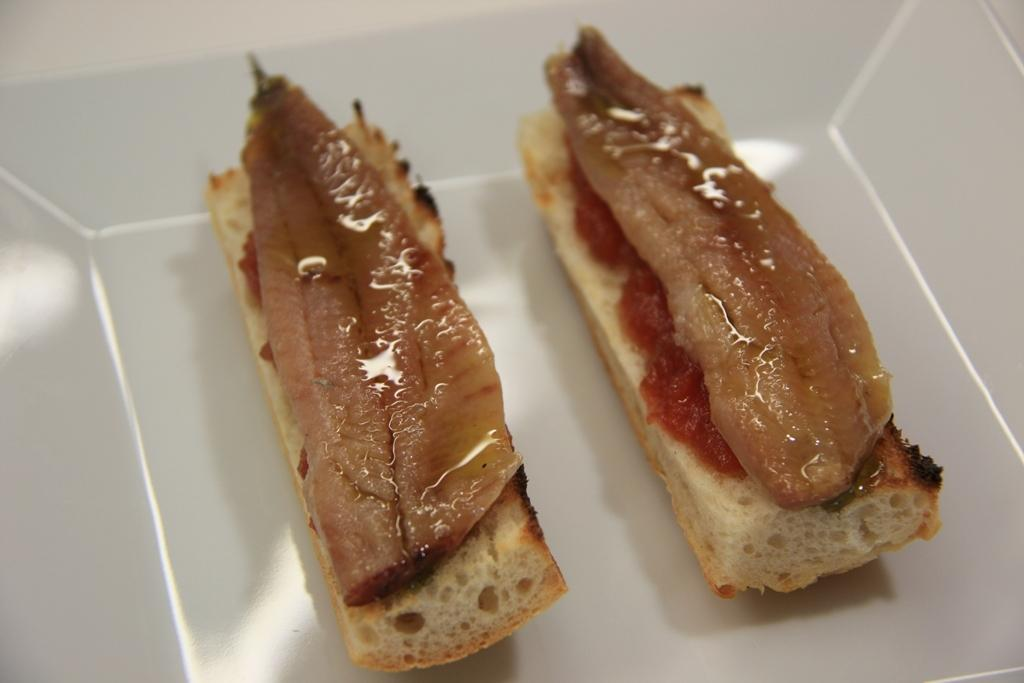What type of items can be seen in the image? There are food items in the image. Where are the food items located? The food items are in a white object. What type of wealth is depicted in the image? There is no depiction of wealth in the image; it features food items in a white object. What type of vessel is used to transport the food items in the image? There is no vessel present in the image; the food items are simply located in a white object. 